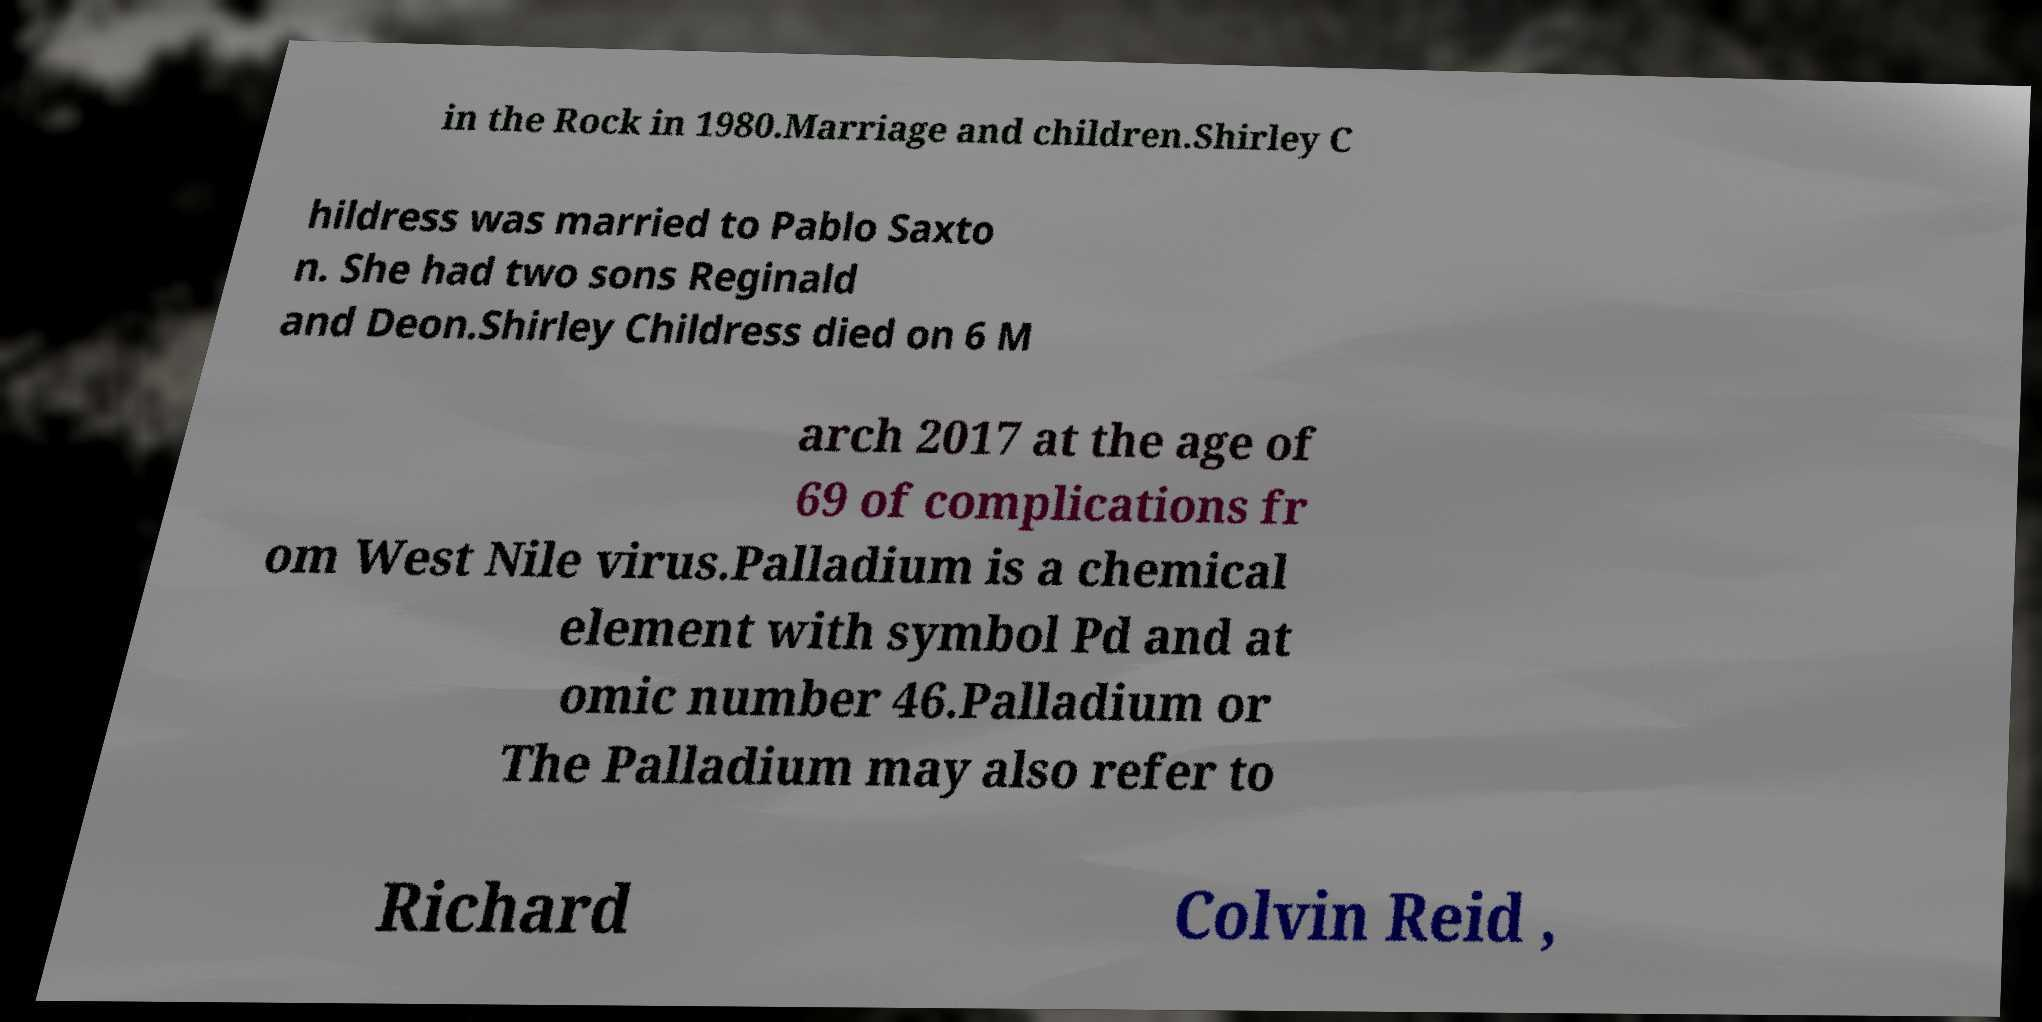Please identify and transcribe the text found in this image. in the Rock in 1980.Marriage and children.Shirley C hildress was married to Pablo Saxto n. She had two sons Reginald and Deon.Shirley Childress died on 6 M arch 2017 at the age of 69 of complications fr om West Nile virus.Palladium is a chemical element with symbol Pd and at omic number 46.Palladium or The Palladium may also refer to Richard Colvin Reid , 